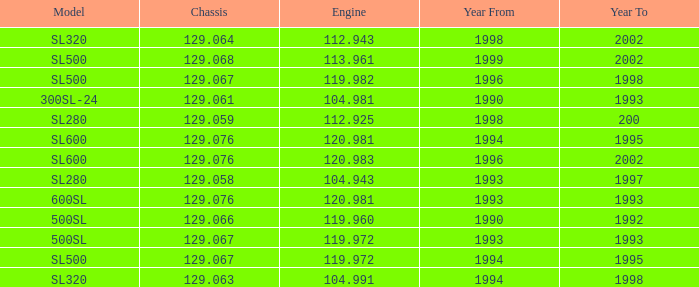Which Engine has a Model of sl500, and a Chassis smaller than 129.067? None. 